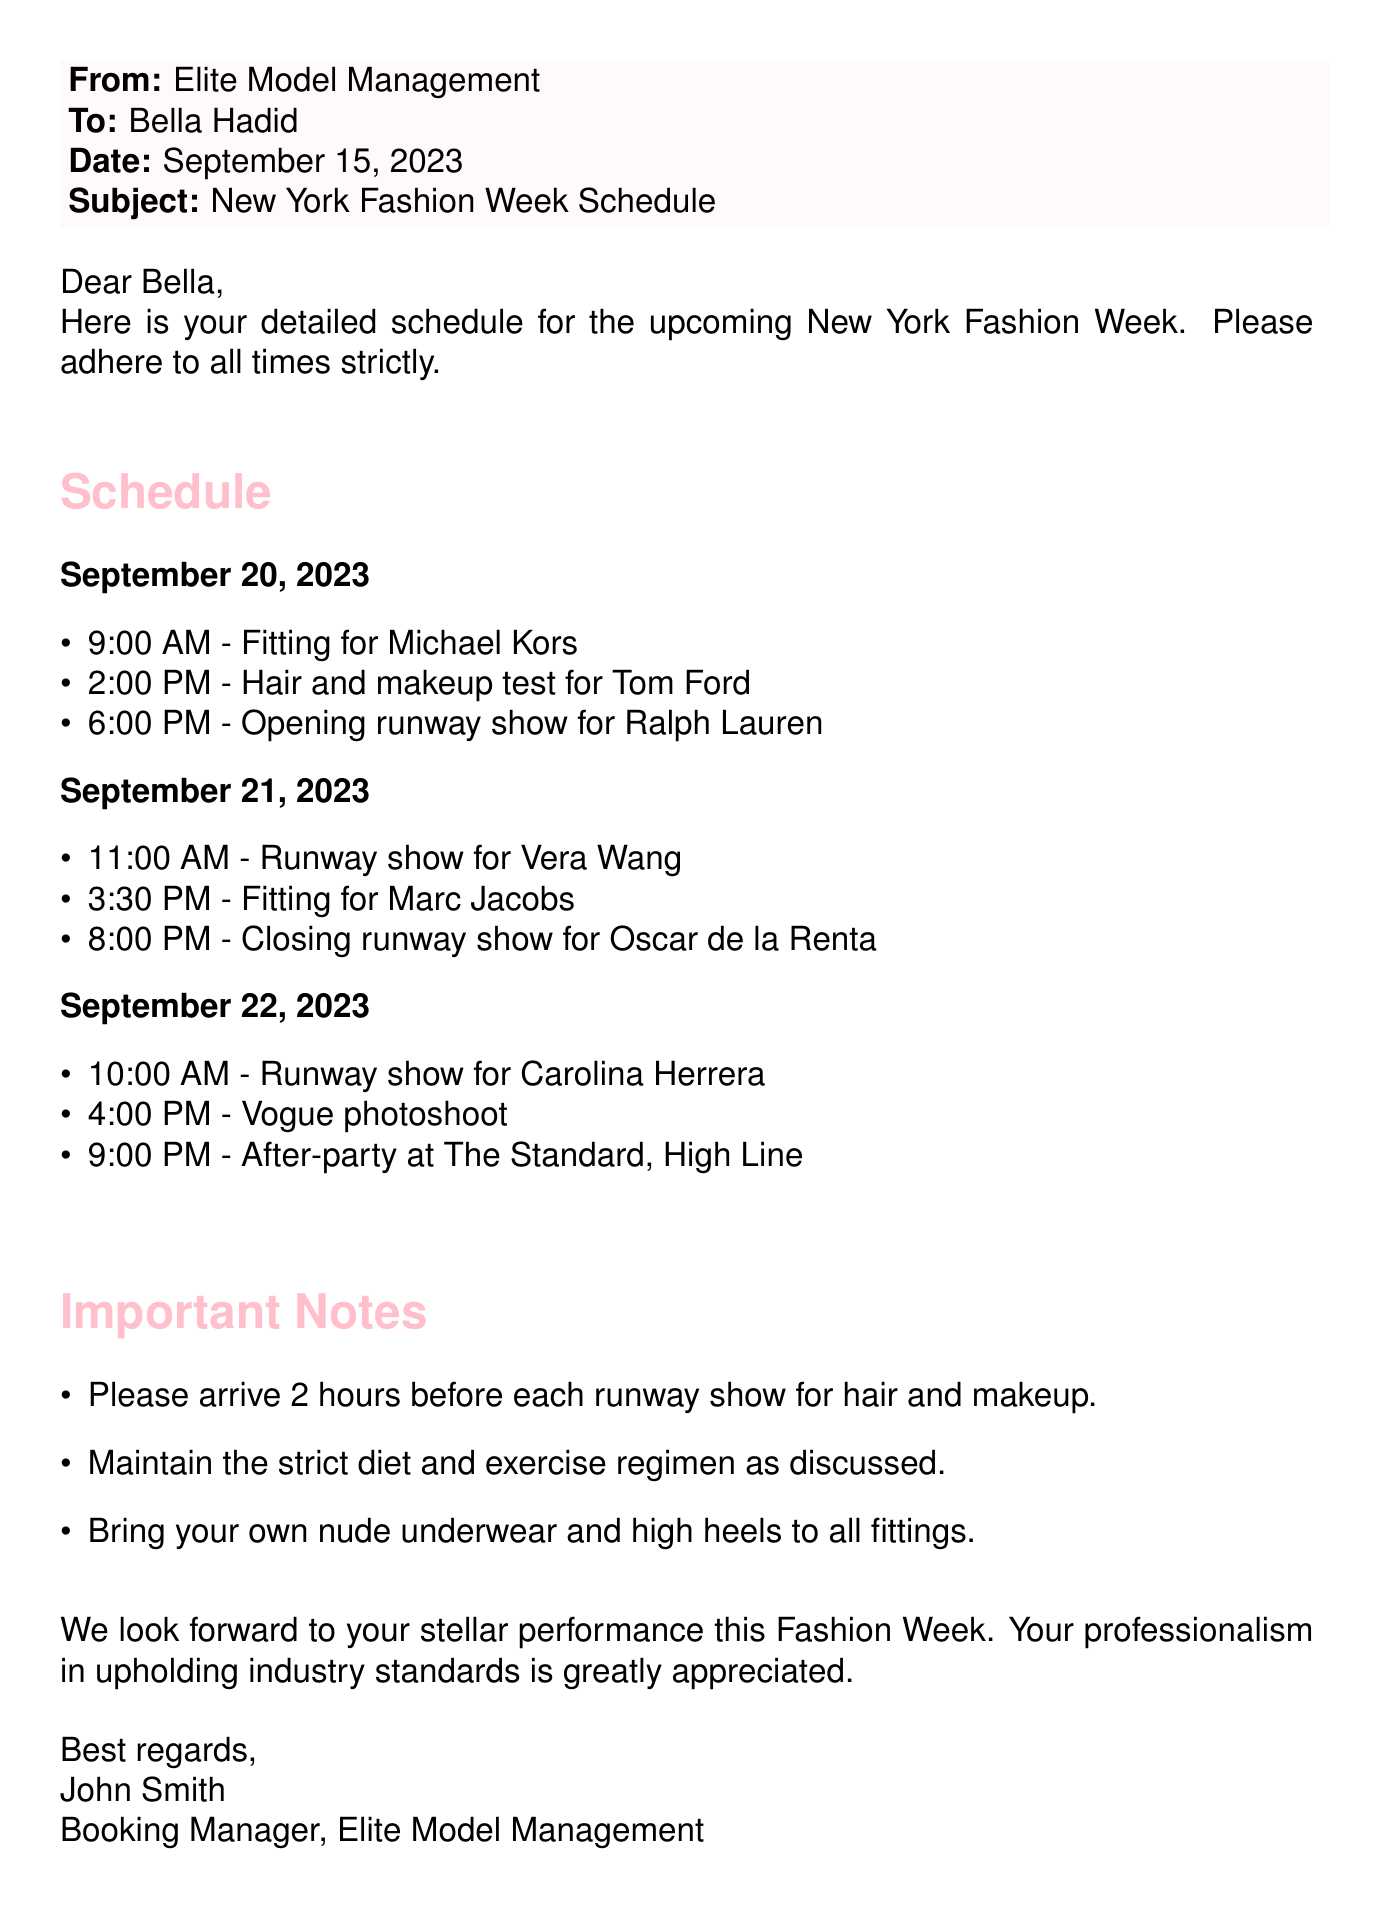what date does the fashion week start? The fashion week starts on September 20, 2023, which is clearly stated at the beginning of the schedule.
Answer: September 20, 2023 how many runway shows are scheduled for September 21? There are three events listed on September 21, two of which are runway shows: one at 11:00 AM and another at 8:00 PM.
Answer: 2 what time is the fitting for Michael Kors? The fitting for Michael Kors is at 9:00 AM on September 20, 2023, as mentioned in the schedule.
Answer: 9:00 AM what is the location of the after-party? The after-party is specified to be at The Standard, High Line in the document.
Answer: The Standard, High Line what should the model bring to all fittings? The document states that the model should bring her own nude underwear and high heels to all fittings.
Answer: nude underwear and high heels how many hours in advance must the model arrive for hair and makeup? The note in the document instructs the model to arrive 2 hours before each runway show for hair and makeup.
Answer: 2 hours what is the last event mentioned in the schedule? The last event in the schedule is the after-party at 9:00 PM on September 22, 2023.
Answer: after-party who is the booking manager at Elite Model Management? The document indicates that John Smith is the Booking Manager at Elite Model Management.
Answer: John Smith 